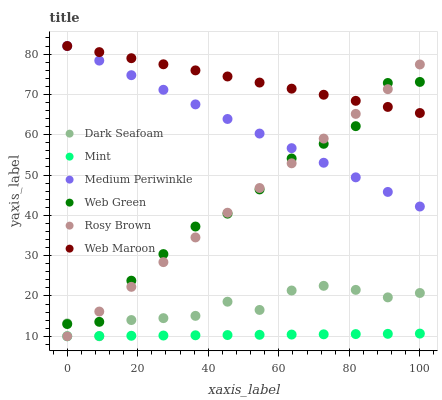Does Mint have the minimum area under the curve?
Answer yes or no. Yes. Does Web Maroon have the maximum area under the curve?
Answer yes or no. Yes. Does Rosy Brown have the minimum area under the curve?
Answer yes or no. No. Does Rosy Brown have the maximum area under the curve?
Answer yes or no. No. Is Mint the smoothest?
Answer yes or no. Yes. Is Web Green the roughest?
Answer yes or no. Yes. Is Rosy Brown the smoothest?
Answer yes or no. No. Is Rosy Brown the roughest?
Answer yes or no. No. Does Rosy Brown have the lowest value?
Answer yes or no. Yes. Does Web Maroon have the lowest value?
Answer yes or no. No. Does Web Maroon have the highest value?
Answer yes or no. Yes. Does Rosy Brown have the highest value?
Answer yes or no. No. Is Mint less than Web Green?
Answer yes or no. Yes. Is Web Maroon greater than Dark Seafoam?
Answer yes or no. Yes. Does Mint intersect Rosy Brown?
Answer yes or no. Yes. Is Mint less than Rosy Brown?
Answer yes or no. No. Is Mint greater than Rosy Brown?
Answer yes or no. No. Does Mint intersect Web Green?
Answer yes or no. No. 